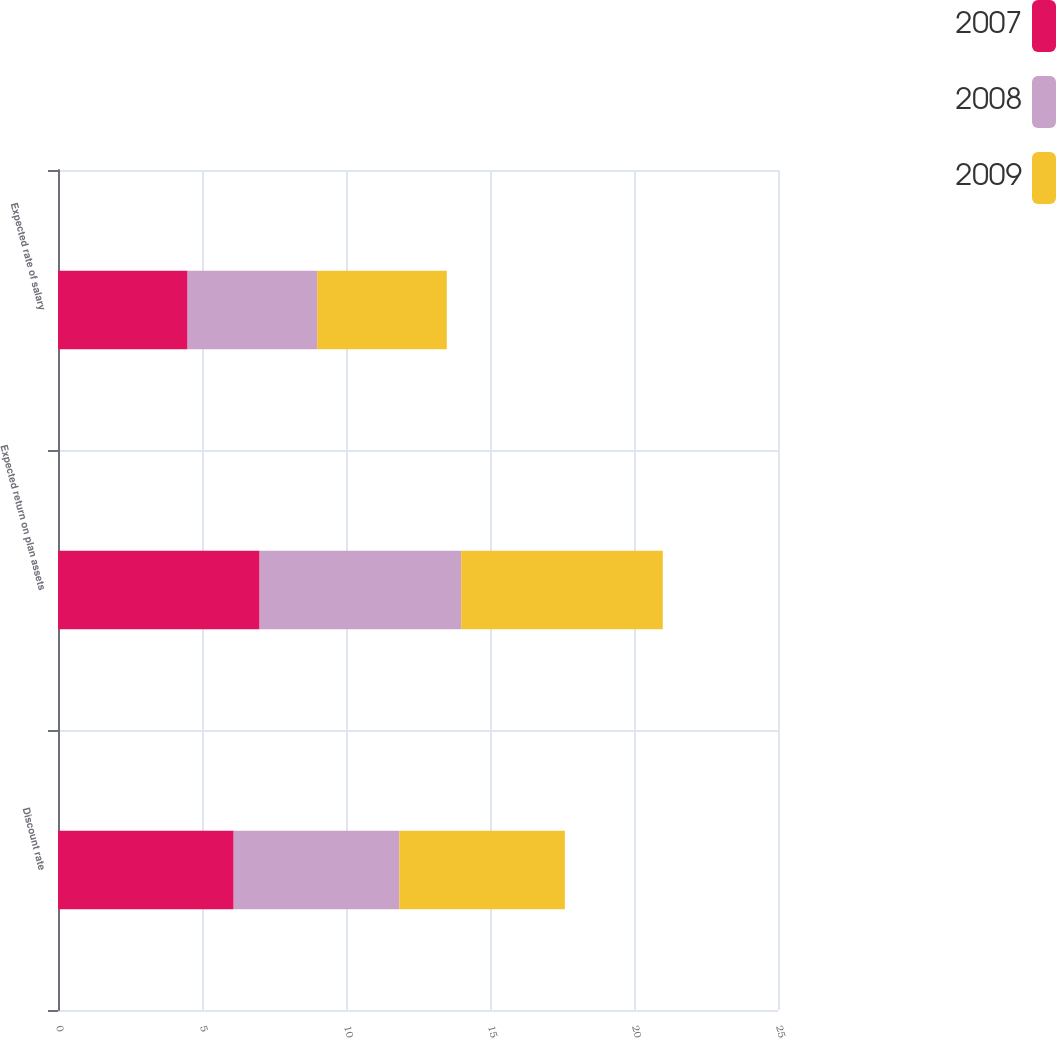Convert chart. <chart><loc_0><loc_0><loc_500><loc_500><stacked_bar_chart><ecel><fcel>Discount rate<fcel>Expected return on plan assets<fcel>Expected rate of salary<nl><fcel>2007<fcel>6.1<fcel>7<fcel>4.5<nl><fcel>2008<fcel>5.75<fcel>7<fcel>4.5<nl><fcel>2009<fcel>5.75<fcel>7<fcel>4.5<nl></chart> 